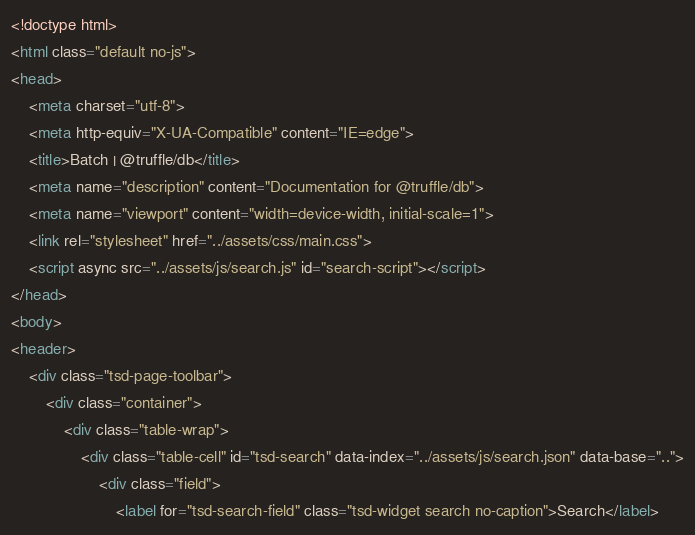Convert code to text. <code><loc_0><loc_0><loc_500><loc_500><_HTML_><!doctype html>
<html class="default no-js">
<head>
	<meta charset="utf-8">
	<meta http-equiv="X-UA-Compatible" content="IE=edge">
	<title>Batch | @truffle/db</title>
	<meta name="description" content="Documentation for @truffle/db">
	<meta name="viewport" content="width=device-width, initial-scale=1">
	<link rel="stylesheet" href="../assets/css/main.css">
	<script async src="../assets/js/search.js" id="search-script"></script>
</head>
<body>
<header>
	<div class="tsd-page-toolbar">
		<div class="container">
			<div class="table-wrap">
				<div class="table-cell" id="tsd-search" data-index="../assets/js/search.json" data-base="..">
					<div class="field">
						<label for="tsd-search-field" class="tsd-widget search no-caption">Search</label></code> 